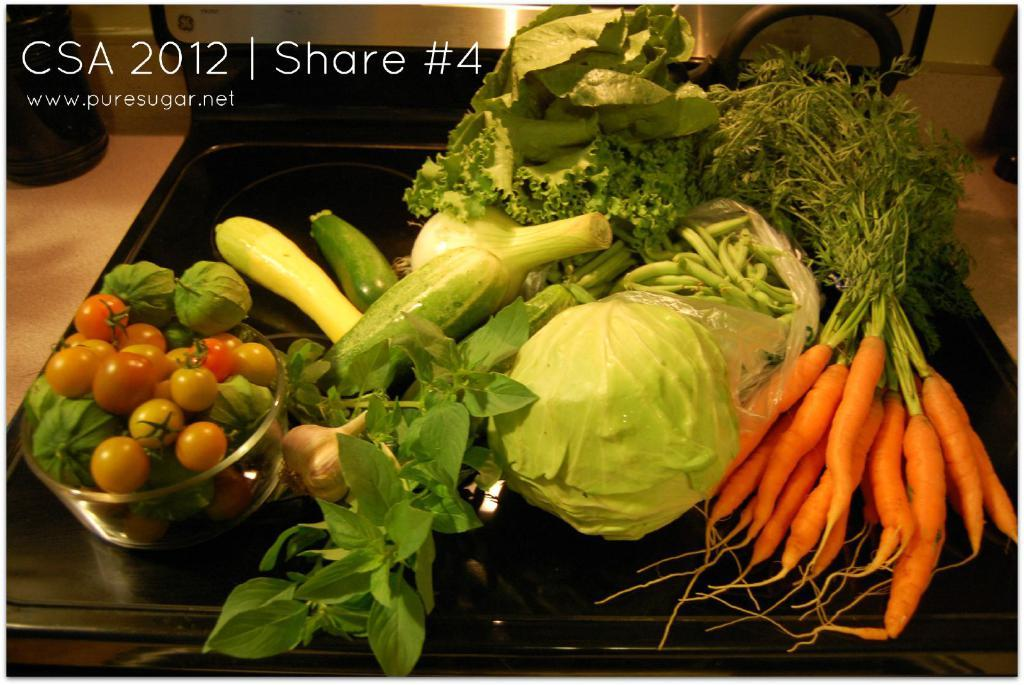What type of food can be seen in the image? There are vegetables in the image. What color is the surface the vegetables are on? The surface the vegetables are on is black. What is located at the top of the image? There is text at the top of the image. What is the tendency of the face of the actor in the image? There is no face or actor present in the image; it only contains vegetables and text. 